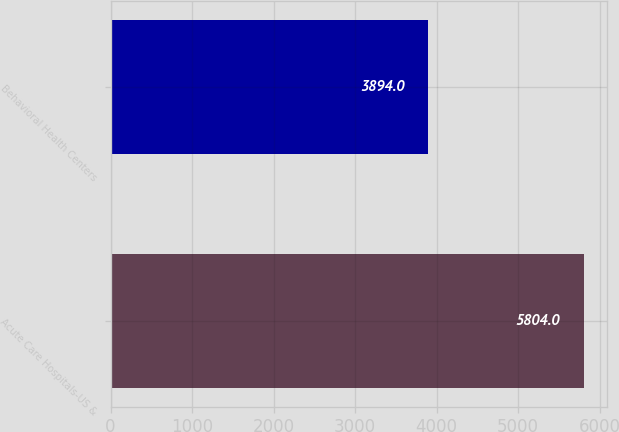Convert chart to OTSL. <chart><loc_0><loc_0><loc_500><loc_500><bar_chart><fcel>Acute Care Hospitals-US &<fcel>Behavioral Health Centers<nl><fcel>5804<fcel>3894<nl></chart> 